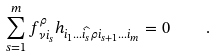<formula> <loc_0><loc_0><loc_500><loc_500>\sum _ { s = 1 } ^ { m } f ^ { \rho } _ { \nu i _ { s } } h _ { i _ { 1 } \dots \widehat { i _ { s } } \rho i _ { s + 1 } \dots i _ { m } } = 0 \quad .</formula> 